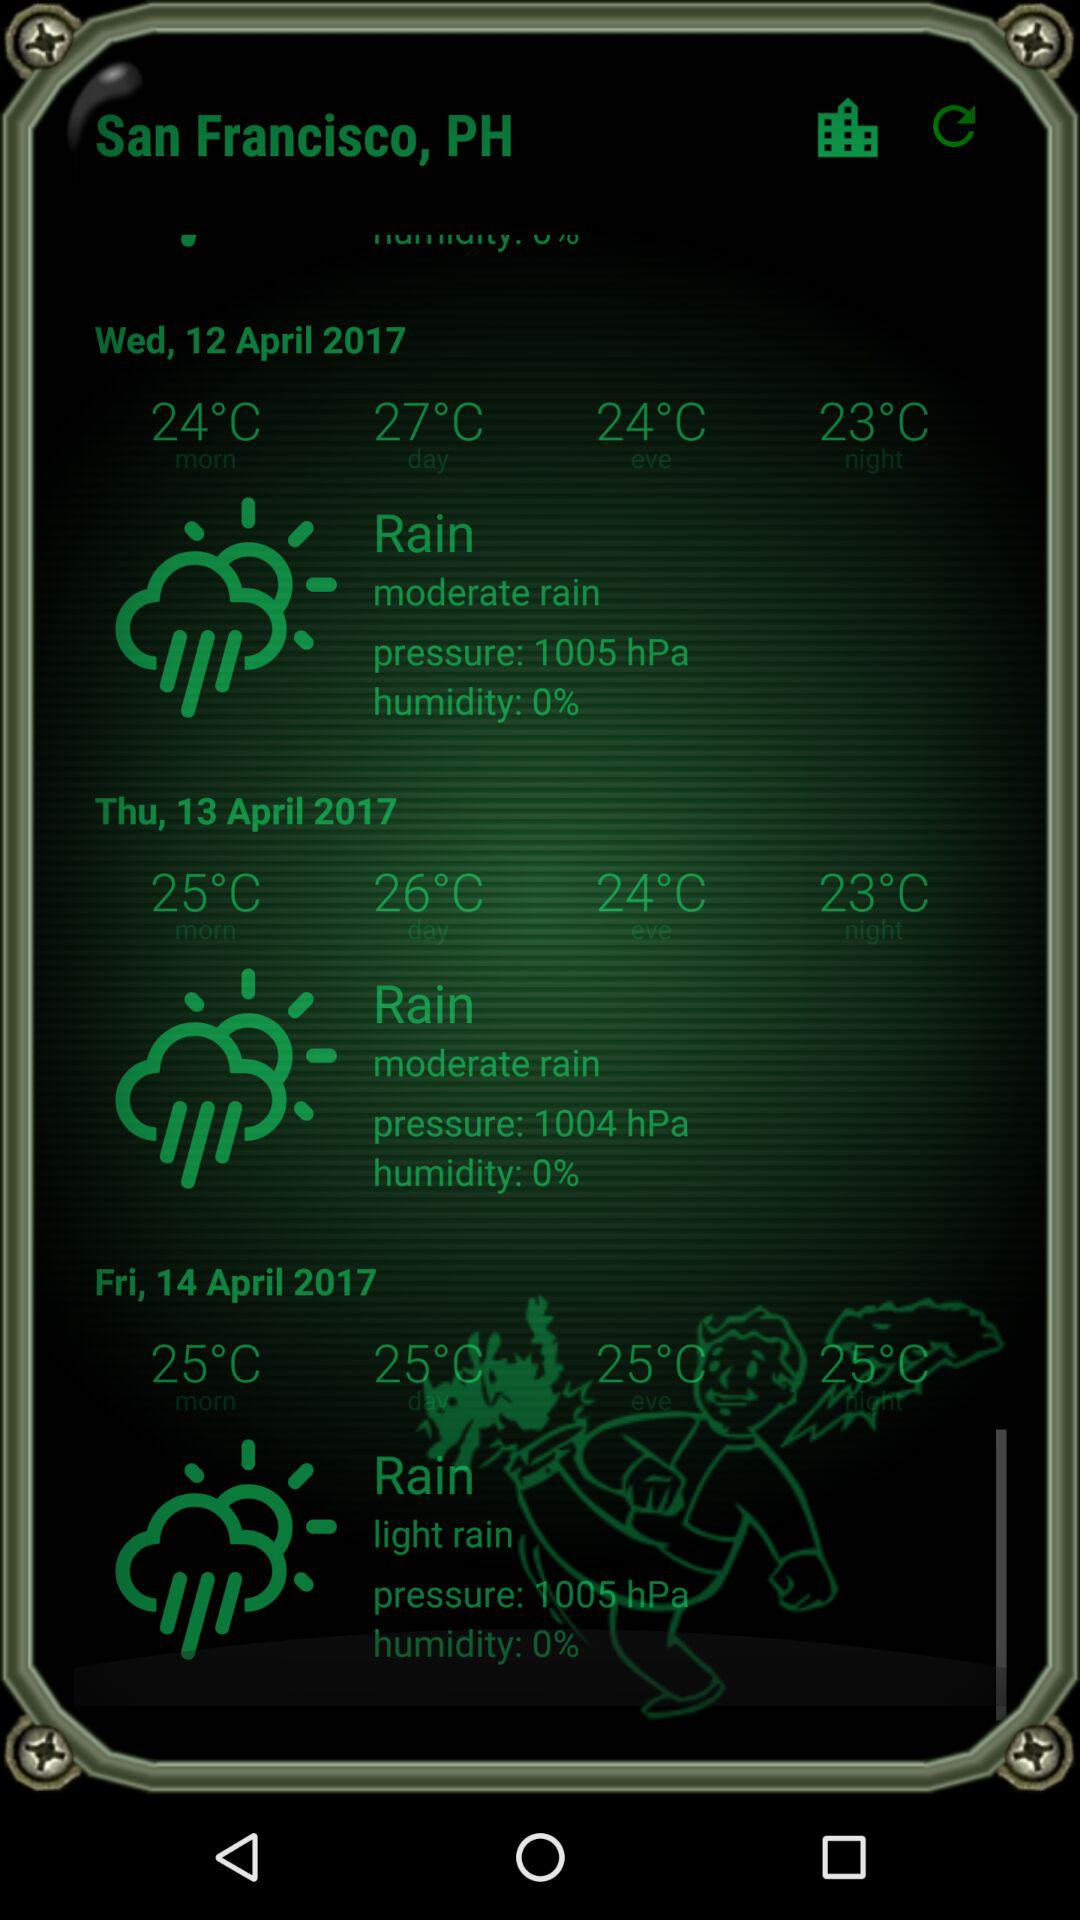What is the temperature at night on Thursday? The temperature is 23 °C. 